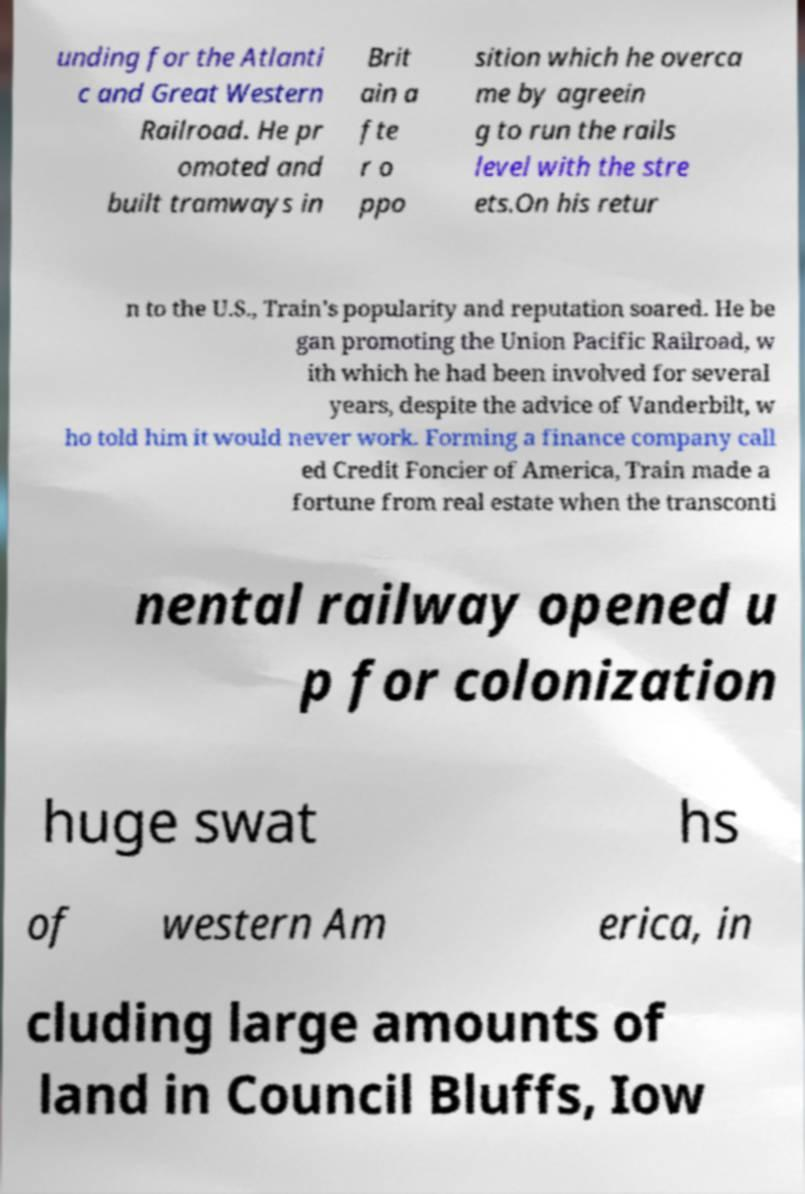Could you extract and type out the text from this image? unding for the Atlanti c and Great Western Railroad. He pr omoted and built tramways in Brit ain a fte r o ppo sition which he overca me by agreein g to run the rails level with the stre ets.On his retur n to the U.S., Train's popularity and reputation soared. He be gan promoting the Union Pacific Railroad, w ith which he had been involved for several years, despite the advice of Vanderbilt, w ho told him it would never work. Forming a finance company call ed Credit Foncier of America, Train made a fortune from real estate when the transconti nental railway opened u p for colonization huge swat hs of western Am erica, in cluding large amounts of land in Council Bluffs, Iow 